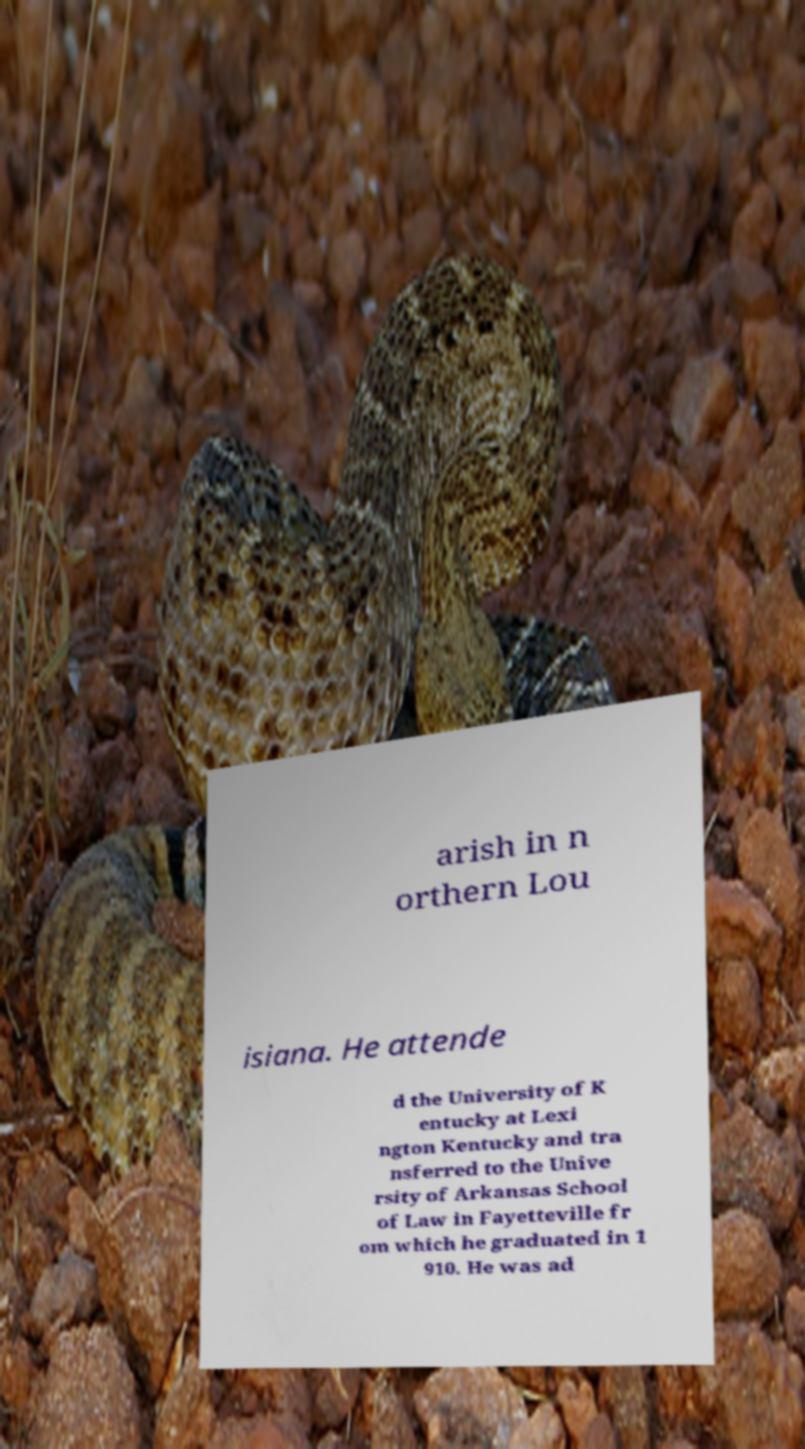For documentation purposes, I need the text within this image transcribed. Could you provide that? arish in n orthern Lou isiana. He attende d the University of K entucky at Lexi ngton Kentucky and tra nsferred to the Unive rsity of Arkansas School of Law in Fayetteville fr om which he graduated in 1 910. He was ad 